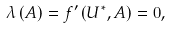Convert formula to latex. <formula><loc_0><loc_0><loc_500><loc_500>\lambda \left ( A \right ) = f ^ { \prime } \left ( U ^ { \ast } , A \right ) = 0 ,</formula> 